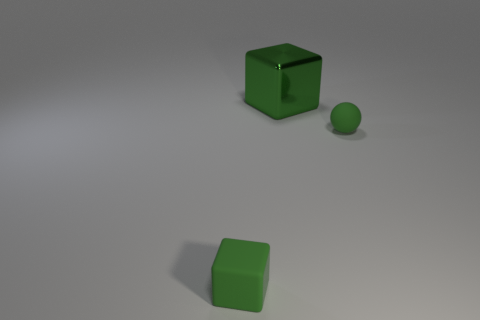Add 1 yellow metal things. How many objects exist? 4 Subtract all balls. How many objects are left? 2 Subtract 1 green blocks. How many objects are left? 2 Subtract all green metal blocks. Subtract all big red cylinders. How many objects are left? 2 Add 1 tiny green matte things. How many tiny green matte things are left? 3 Add 1 tiny purple matte objects. How many tiny purple matte objects exist? 1 